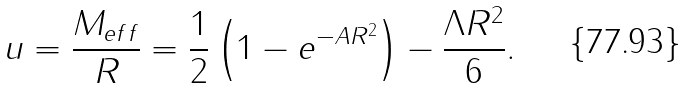<formula> <loc_0><loc_0><loc_500><loc_500>u = \frac { M _ { e f f } } { R } = \frac { 1 } { 2 } \left ( 1 - e ^ { - A R ^ { 2 } } \right ) - \frac { \Lambda R ^ { 2 } } { 6 } .</formula> 